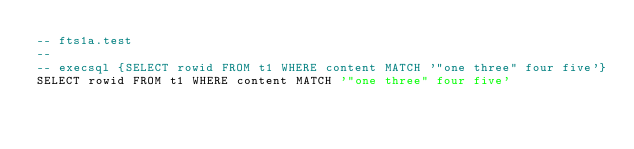Convert code to text. <code><loc_0><loc_0><loc_500><loc_500><_SQL_>-- fts1a.test
-- 
-- execsql {SELECT rowid FROM t1 WHERE content MATCH '"one three" four five'}
SELECT rowid FROM t1 WHERE content MATCH '"one three" four five'</code> 